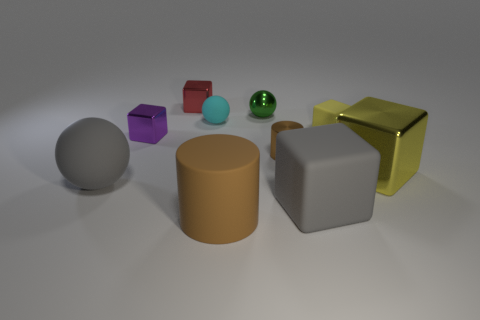Subtract all tiny red metallic blocks. How many blocks are left? 4 Subtract 2 cubes. How many cubes are left? 3 Subtract all blue cubes. Subtract all yellow balls. How many cubes are left? 5 Subtract all spheres. How many objects are left? 7 Subtract all brown matte cylinders. Subtract all purple cubes. How many objects are left? 8 Add 4 tiny cyan matte balls. How many tiny cyan matte balls are left? 5 Add 1 small gray cylinders. How many small gray cylinders exist? 1 Subtract 1 cyan spheres. How many objects are left? 9 